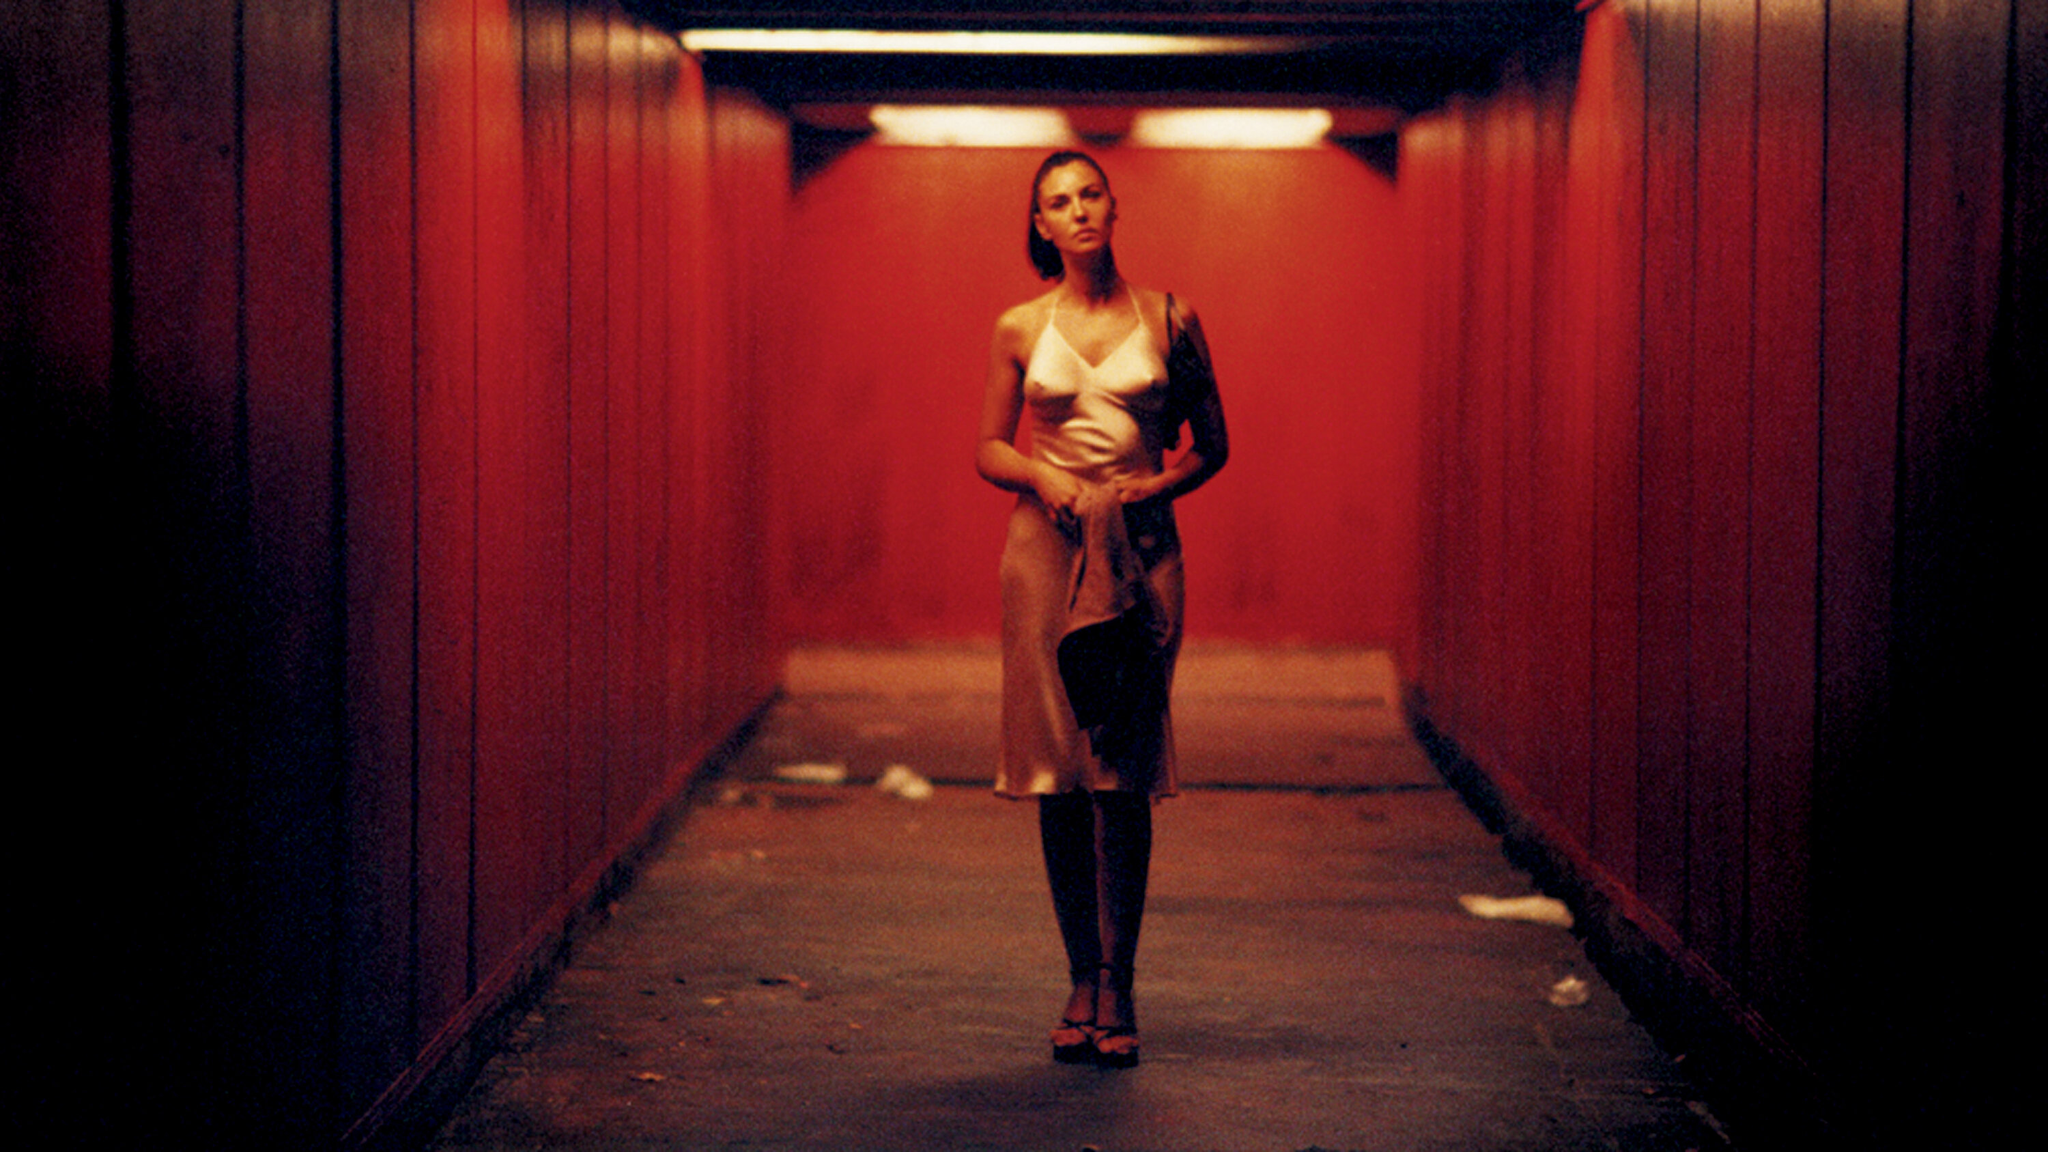What is this photo about? The photo portrays a woman standing alone in a tunnel, illuminated by a red light that casts an intense glow on the surroundings and her figure. She wears an elegant beige and black dress and high heels, with her arms folded and gaze directed off-camera, suggesting a narrative of anticipation or reflection. The stark contrast between the red walls of the tunnel and the litter on the ground adds a layer of complexity, evoking themes of beauty amidst decay or neglect. 